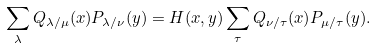<formula> <loc_0><loc_0><loc_500><loc_500>\sum _ { \lambda } Q _ { \lambda / \mu } ( x ) P _ { \lambda / \nu } ( y ) = H ( x , y ) \sum _ { \tau } Q _ { \nu / \tau } ( x ) P _ { \mu / \tau } ( y ) .</formula> 